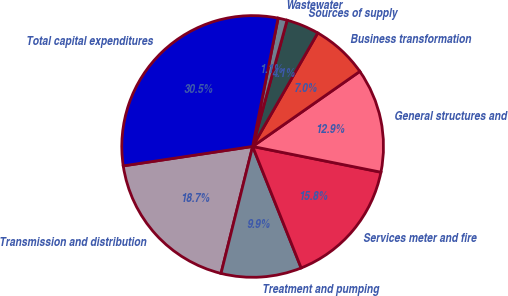<chart> <loc_0><loc_0><loc_500><loc_500><pie_chart><fcel>Transmission and distribution<fcel>Treatment and pumping<fcel>Services meter and fire<fcel>General structures and<fcel>Business transformation<fcel>Sources of supply<fcel>Wastewater<fcel>Total capital expenditures<nl><fcel>18.74%<fcel>9.93%<fcel>15.8%<fcel>12.87%<fcel>6.99%<fcel>4.05%<fcel>1.12%<fcel>30.49%<nl></chart> 